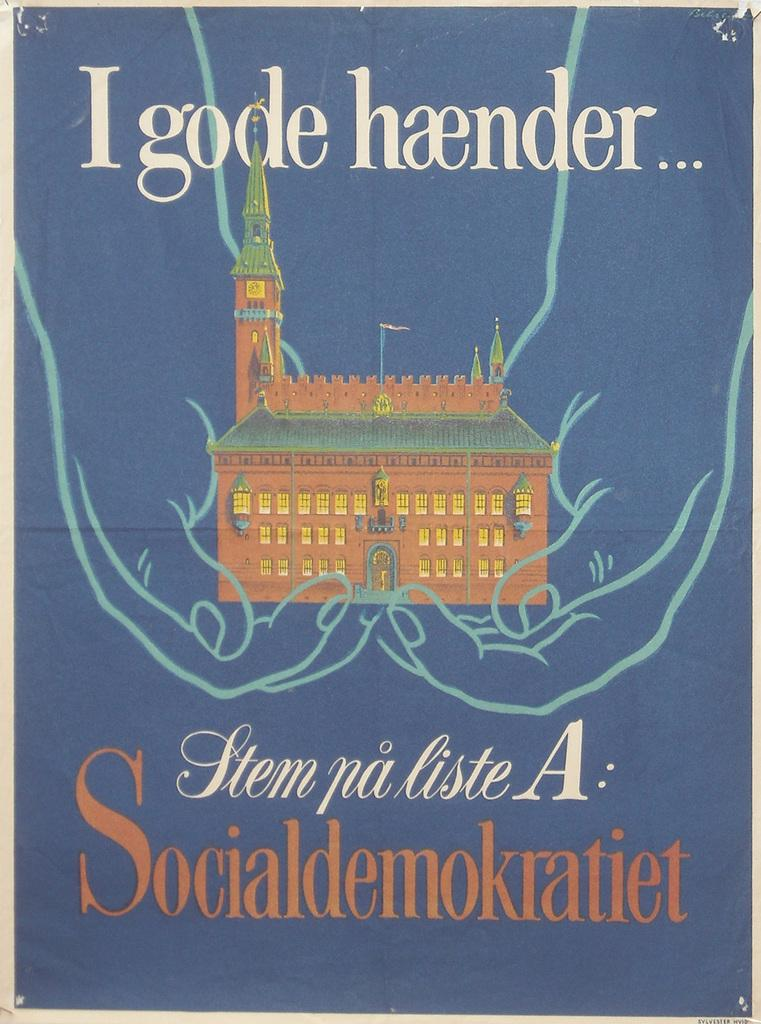What is being held by the hands in the image? There are hands holding a building in the image. What can be seen at the top of the image? There is text at the top of the image. What can be seen at the bottom of the image? There is text at the bottom of the image. What type of plant is growing in the image? There is no plant present in the image. What belief system is being represented in the image? The image does not depict any specific belief system. 